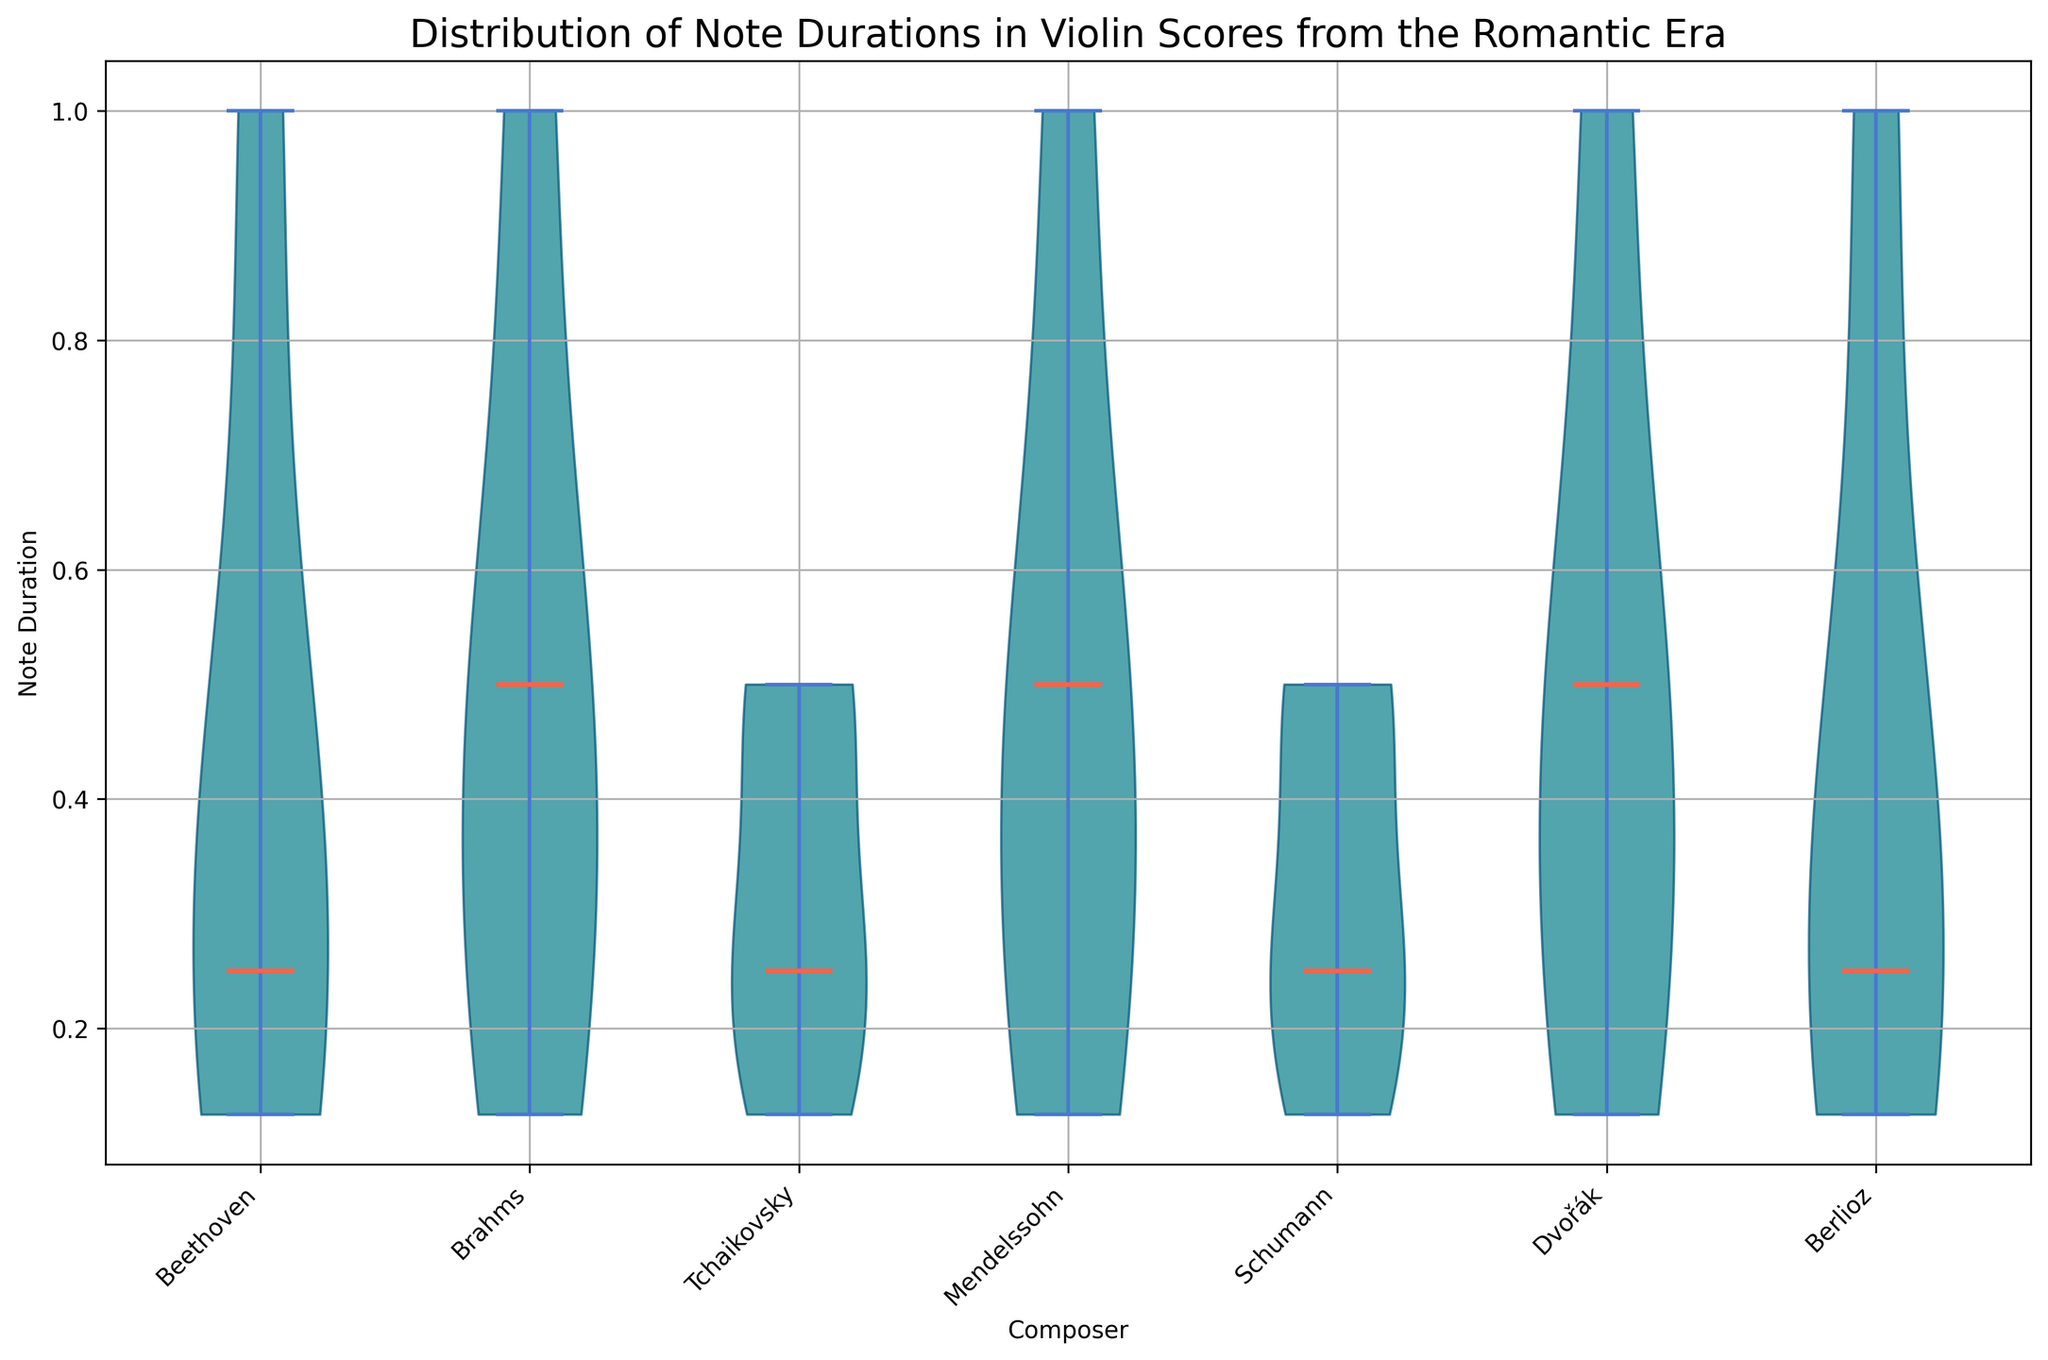Which composer shows the widest range of note durations in their violin scores? To determine the composer with the widest range of note durations, look for the conductor whose violin plot stretches the most vertically. This means we find the composer whose range extends from the lowest note duration (the smallest value) to the highest note duration (the largest value).
Answer: Dvořák Which composer has the most concentrated distribution of note durations? To answer this, we look for the violin plot with the narrowest and tallest shape, indicating that most of the data points are concentrated around the median value.
Answer: Schumann What is the median note duration for Beethoven's Violin Sonata No. 5? The median note duration is represented by the horizontal line through the middle of the violin plot. For Beethoven, find the red horizontal line within the violin plot labeled "Beethoven."
Answer: 0.25 Which composer's violin score has more variation in note durations, Brahms or Mendelssohn? To compare variations, observe the widths and spreads of the violin plots for Brahms and Mendelssohn. The plot with more spread indicates more variation in note durations.
Answer: Brahms What is the maximum note duration present in Berlioz's "Harold en Italie"? The maximum note duration can be identified as the highest point where the violin plot for Berlioz extends. Locate the top end of Berlioz's violin plot.
Answer: 1 How do the median note durations for Tchaikovsky and Beethoven compare? Look for the red horizontal lines representing the medians within the violin plots for both Tchaikovsky and Beethoven, and compare their positions.
Answer: Both are 0.25 What can be said about the note duration spread in Schumann's music compared to Tchaikovsky's music? Compare the vertical spread of Schumann's and Tchaikovsky's violin plots. Schumann's plot is narrower and taller, indicating a smaller spread, while Tchaikovsky's plot is wider, indicating a larger spread.
Answer: Schumann's music has a narrower spread than Tchaikovsky's Which composer has the smallest median note duration, and what is it? Identify the red horizontal line at its lowest position within any of the violin plots to find the smallest median note duration.
Answer: All composers have the same median note duration of 0.25 Between which range do most note durations of Dvořák's violin compositions fall? Observe the thickest part of Dvořák's violin plot to determine the range where most data points are concentrated.
Answer: Between 0.25 and 0.5 What is the general trend observed in the note durations across different composers of the Romantic Era violin scores? Analyze the overall shapes and spreads of the violin plots for all composers to determine a common pattern or trend.
Answer: Most note durations center around short values, typically 0.25 or 0.5 seconds 